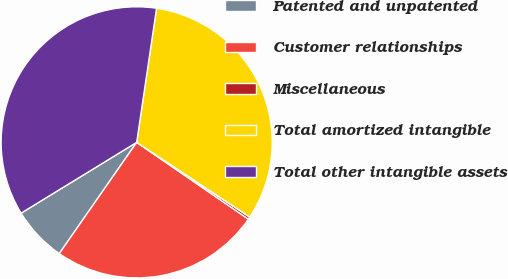<chart> <loc_0><loc_0><loc_500><loc_500><pie_chart><fcel>Patented and unpatented<fcel>Customer relationships<fcel>Miscellaneous<fcel>Total amortized intangible<fcel>Total other intangible assets<nl><fcel>6.58%<fcel>25.09%<fcel>0.29%<fcel>31.96%<fcel>36.09%<nl></chart> 